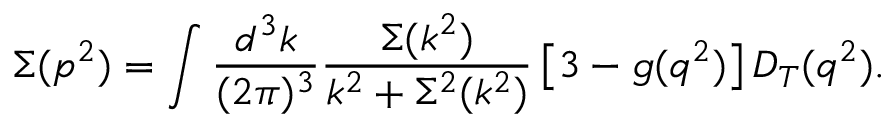<formula> <loc_0><loc_0><loc_500><loc_500>\Sigma ( p ^ { 2 } ) = \int \frac { d ^ { 3 } k } { ( 2 \pi ) ^ { 3 } } \frac { \Sigma ( k ^ { 2 } ) } { k ^ { 2 } + \Sigma ^ { 2 } ( k ^ { 2 } ) } \left [ 3 - g ( q ^ { 2 } ) \right ] D _ { T } ( q ^ { 2 } ) .</formula> 